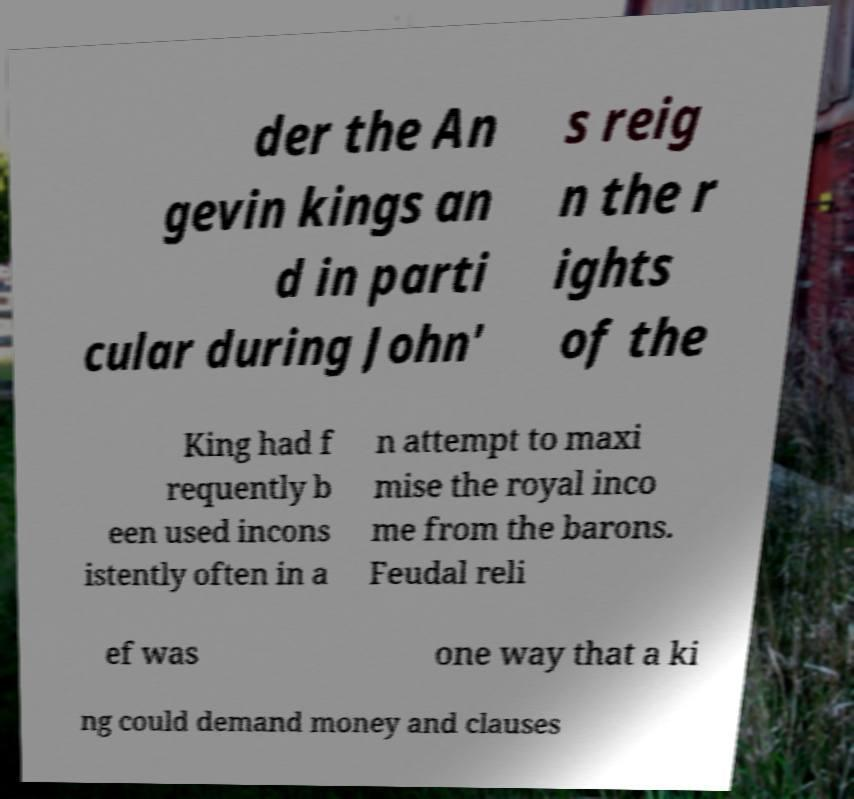Can you read and provide the text displayed in the image?This photo seems to have some interesting text. Can you extract and type it out for me? der the An gevin kings an d in parti cular during John' s reig n the r ights of the King had f requently b een used incons istently often in a n attempt to maxi mise the royal inco me from the barons. Feudal reli ef was one way that a ki ng could demand money and clauses 